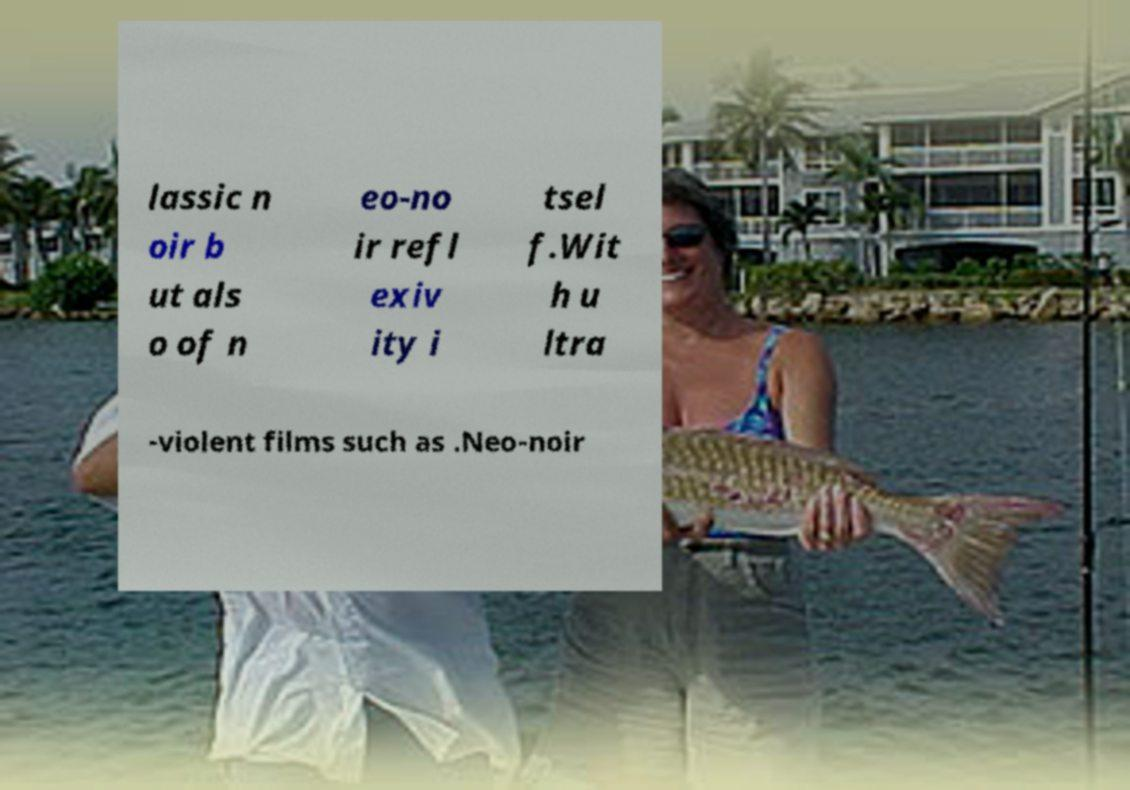Please identify and transcribe the text found in this image. lassic n oir b ut als o of n eo-no ir refl exiv ity i tsel f.Wit h u ltra -violent films such as .Neo-noir 